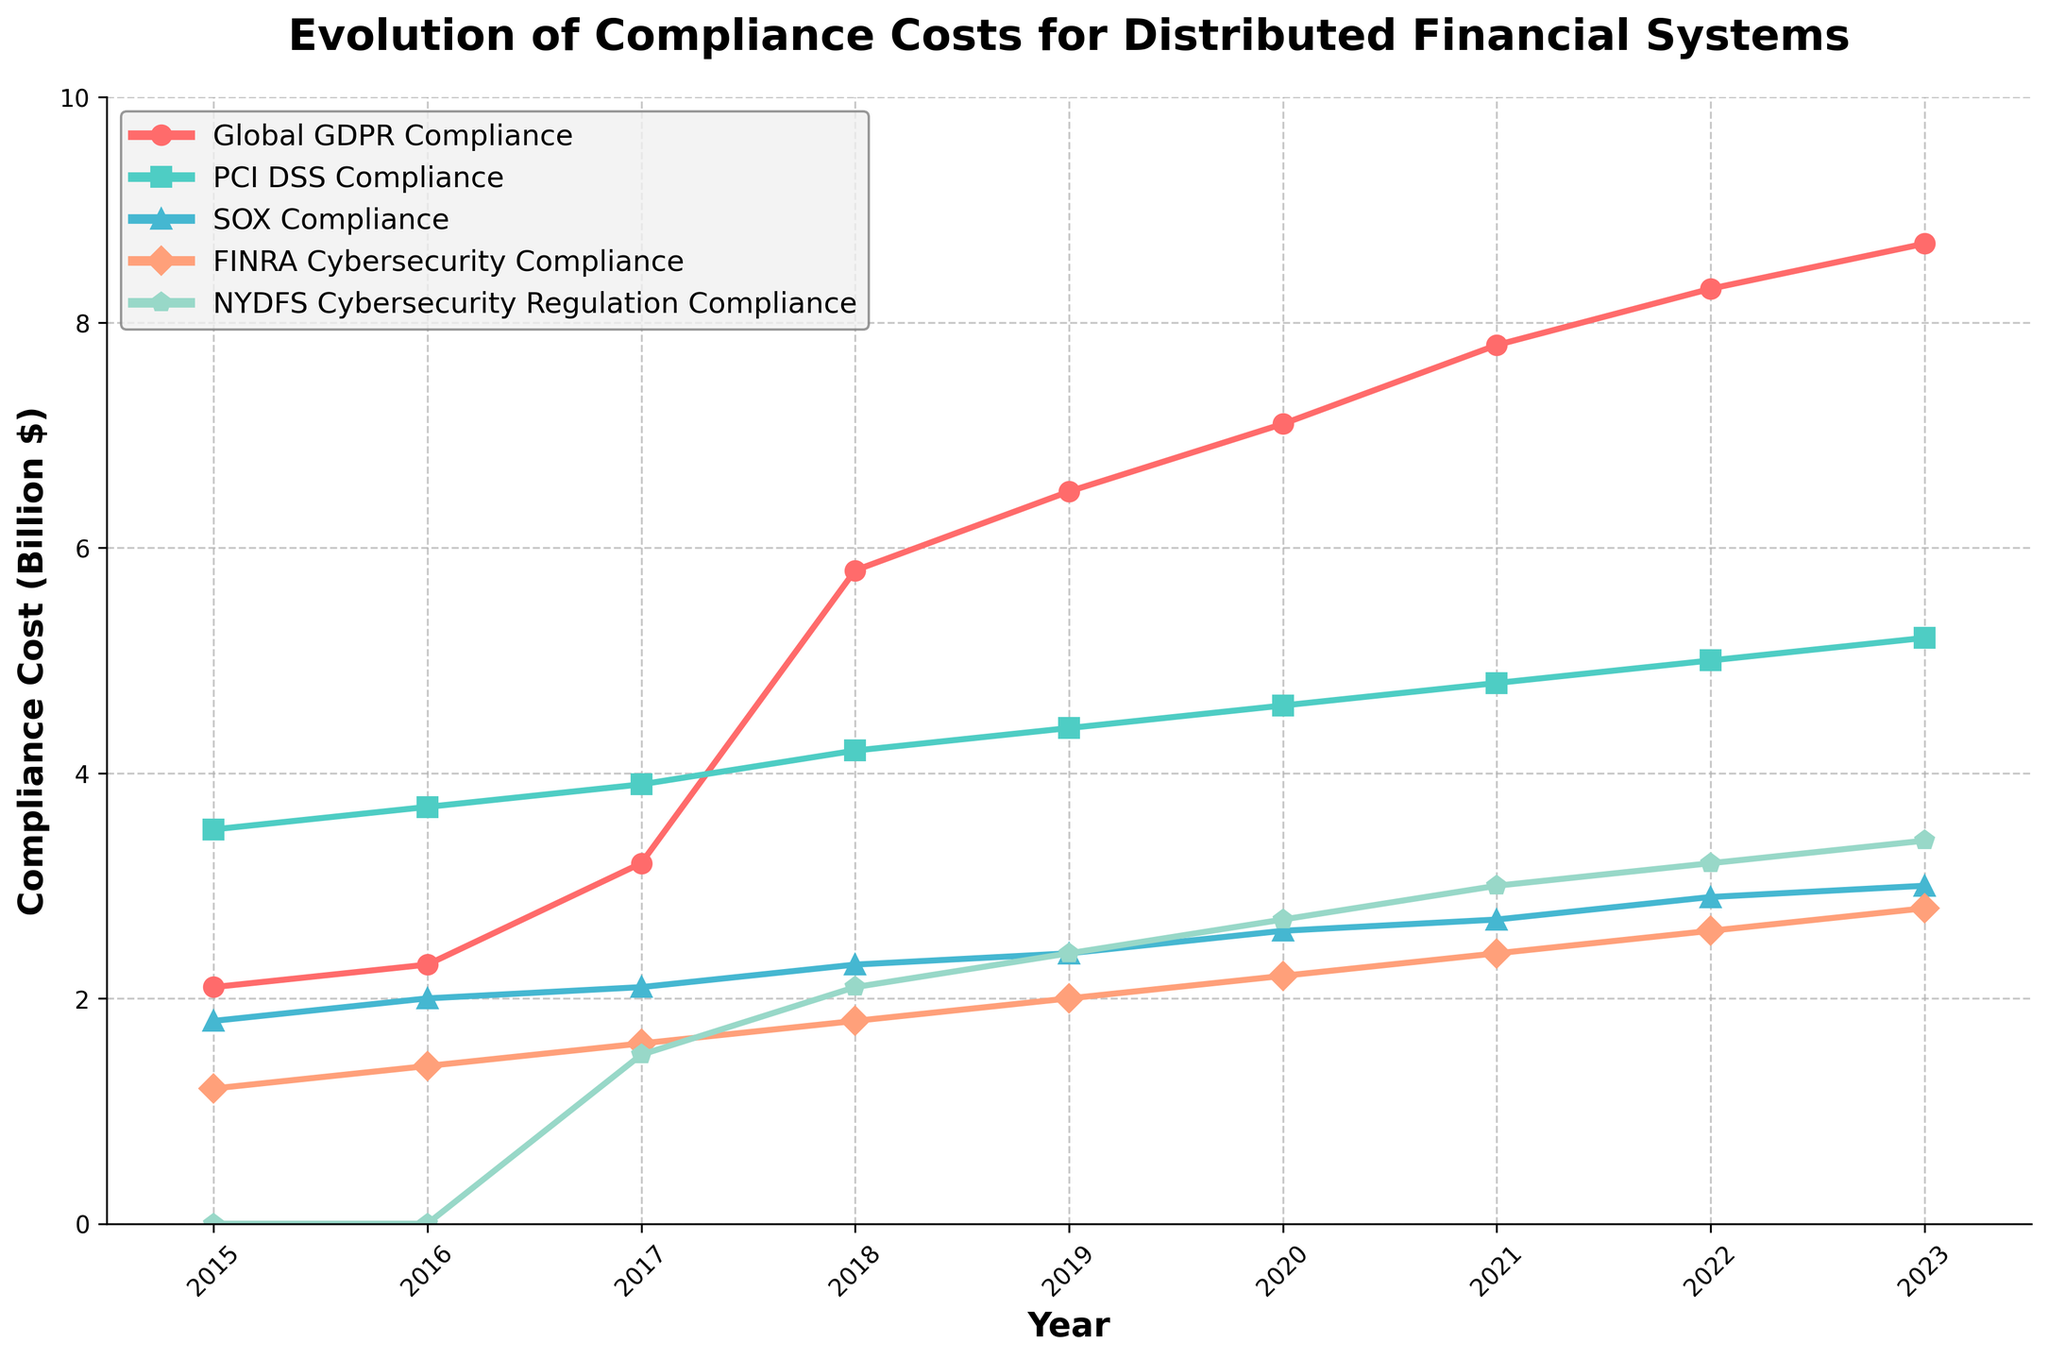What is the peak value of Global GDPR Compliance costs and in which year does it occur? The peak value for Global GDPR Compliance costs on the plot is the highest point on the Global GDPR Compliance line. By observing the plot, this occurs in the year 2023 and the value is 8.7 billion dollars.
Answer: 2023, 8.7 billion dollars In which year did NYDFS Cybersecurity Regulation Compliance costs start increasing? To determine when NYDFS Cybersecurity Regulation Compliance costs started increasing, observe the first year where the line marking NYDFS costs moves upward. This starts in 2017 when the cost increased to 1.5 billion dollars from 0.
Answer: 2017 How much did PCI DSS Compliance costs grow from 2016 to 2022? To determine the growth, identify the costs in 2016 and 2022 for PCI DSS Compliance. In 2016, the cost was 3.7 billion dollars, and in 2022, it was 5.0 billion dollars. Subtract the 2016 cost from the 2022 cost (5.0 - 3.7 = 1.3 billion dollars).
Answer: 1.3 billion dollars Which compliance showed the most significant increase in cost between 2017 and 2023? Evaluate the increase in costs for each compliance line from 2017 to 2023. The Global GDPR Compliance increased from 3.2 to 8.7 billion dollars, making an increase of 5.5 billion dollars. This is the most significant increase when compared to other compliances.
Answer: Global GDPR Compliance Compare the costs of SOX Compliance and FINRA Cybersecurity Compliance in 2020. Which was higher and by how much? Identify the costs in 2020 for SOX Compliance and FINRA Cybersecurity Compliance. SOX Compliance was 2.6 billion dollars, and FINRA Cybersecurity Compliance was 2.2 billion dollars. SOX Compliance was higher by 0.4 billion dollars (2.6 - 2.2 = 0.4).
Answer: SOX Compliance, 0.4 billion dollars What is the average cost of SOX Compliance over the years 2015 to 2023? Calculate the sum of SOX Compliance costs from 2015 to 2023 and divide by the number of years. The sum is (1.8 + 2.0 + 2.1 + 2.3 + 2.4 + 2.6 + 2.7 + 2.9 + 3.0) = 21.8 billion dollars. There are 9 years, so the average is 21.8 / 9.
Answer: 2.42 billion dollars Which compliance had the lowest cost in 2018, and what was the value? Check the values for all compliances in 2018. The lowest cost is 1.8 billion dollars for FINRA Cybersecurity Compliance.
Answer: FINRA Cybersecurity Compliance, 1.8 billion dollars Was there any year where the cost for NYDFS Cybersecurity Regulation Compliance remained the same as the previous year? Observe the line for NYDFS Cybersecurity Regulation Compliance to see if there's any year where the value did not change. There is no such year; the cost increases every year from 2017 onwards without remaining the same.
Answer: No Identify the year when FINRA Cybersecurity Compliance costs first exceeded 2.0 billion dollars. Look for the first year when the FINRA Cybersecurity Compliance costs exceeded 2.0 billion dollars. This happens in 2019 with a cost of 2.0 billion dollars.
Answer: 2019 What is the trend observed for PCI DSS Compliance costs from 2015 to 2023? Follow the PCI DSS Compliance line from 2015 to 2023; the trend shows a steady increase each year from 3.5 to 5.2 billion dollars.
Answer: Steady increase 